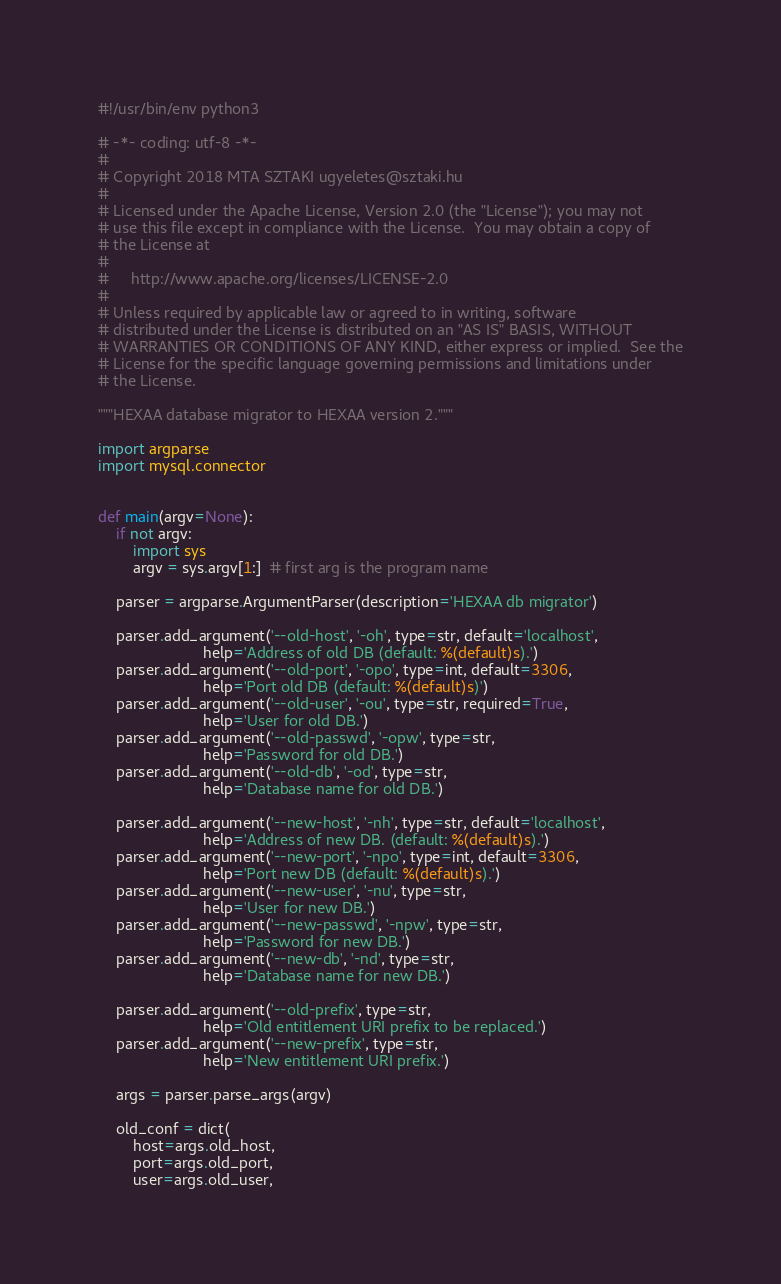<code> <loc_0><loc_0><loc_500><loc_500><_Python_>#!/usr/bin/env python3

# -*- coding: utf-8 -*-
#
# Copyright 2018 MTA SZTAKI ugyeletes@sztaki.hu
#
# Licensed under the Apache License, Version 2.0 (the "License"); you may not
# use this file except in compliance with the License.  You may obtain a copy of
# the License at
#
#     http://www.apache.org/licenses/LICENSE-2.0
#
# Unless required by applicable law or agreed to in writing, software
# distributed under the License is distributed on an "AS IS" BASIS, WITHOUT
# WARRANTIES OR CONDITIONS OF ANY KIND, either express or implied.  See the
# License for the specific language governing permissions and limitations under
# the License.

"""HEXAA database migrator to HEXAA version 2."""

import argparse
import mysql.connector


def main(argv=None):
    if not argv:
        import sys
        argv = sys.argv[1:]  # first arg is the program name

    parser = argparse.ArgumentParser(description='HEXAA db migrator')

    parser.add_argument('--old-host', '-oh', type=str, default='localhost',
                        help='Address of old DB (default: %(default)s).')
    parser.add_argument('--old-port', '-opo', type=int, default=3306,
                        help='Port old DB (default: %(default)s)')
    parser.add_argument('--old-user', '-ou', type=str, required=True,
                        help='User for old DB.')
    parser.add_argument('--old-passwd', '-opw', type=str,
                        help='Password for old DB.')
    parser.add_argument('--old-db', '-od', type=str,
                        help='Database name for old DB.')

    parser.add_argument('--new-host', '-nh', type=str, default='localhost',
                        help='Address of new DB. (default: %(default)s).')
    parser.add_argument('--new-port', '-npo', type=int, default=3306,
                        help='Port new DB (default: %(default)s).')
    parser.add_argument('--new-user', '-nu', type=str,
                        help='User for new DB.')
    parser.add_argument('--new-passwd', '-npw', type=str,
                        help='Password for new DB.')
    parser.add_argument('--new-db', '-nd', type=str,
                        help='Database name for new DB.')

    parser.add_argument('--old-prefix', type=str,
                        help='Old entitlement URI prefix to be replaced.')
    parser.add_argument('--new-prefix', type=str,
                        help='New entitlement URI prefix.')

    args = parser.parse_args(argv)

    old_conf = dict(
        host=args.old_host,
        port=args.old_port,
        user=args.old_user,</code> 